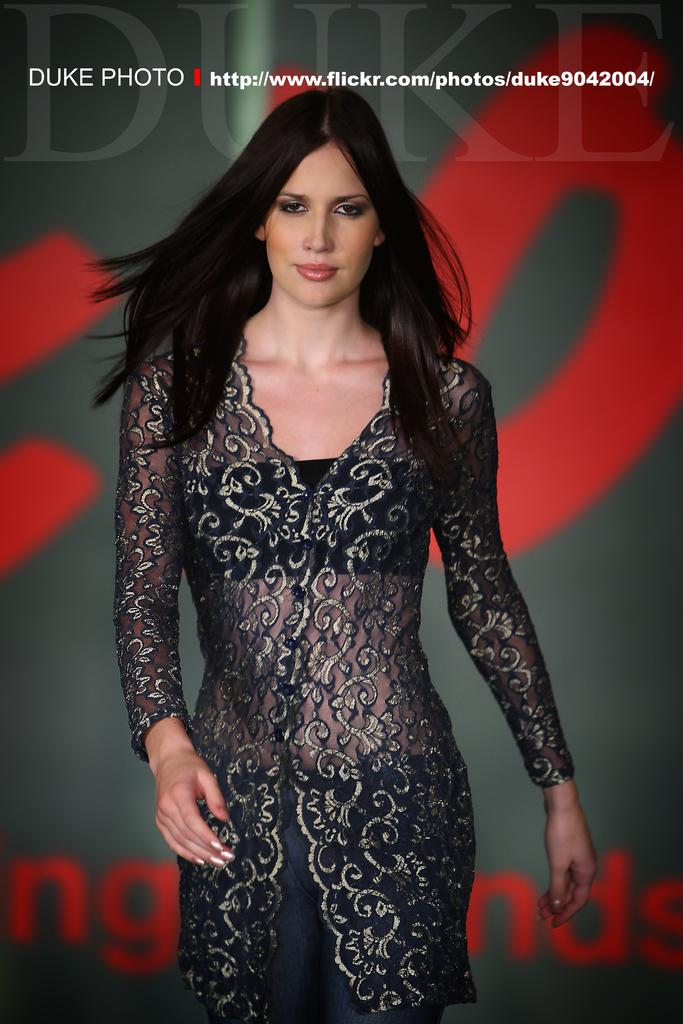Who is present in the image? There is a woman in the image. What else can be seen in the image besides the woman? There is text visible in the background of the image. What type of clouds can be seen in the image? There are no clouds visible in the image; it only features a woman and text in the background. 